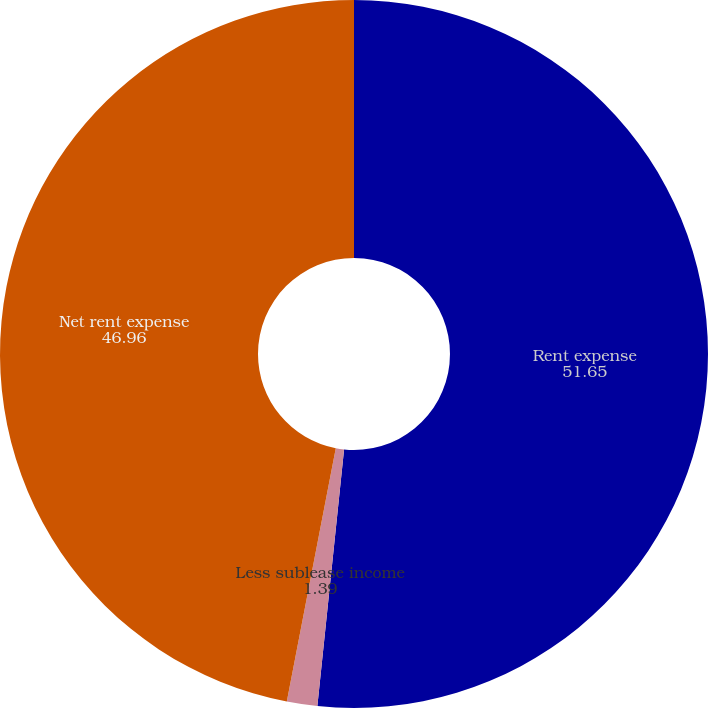<chart> <loc_0><loc_0><loc_500><loc_500><pie_chart><fcel>Rent expense<fcel>Less sublease income<fcel>Net rent expense<nl><fcel>51.65%<fcel>1.39%<fcel>46.96%<nl></chart> 